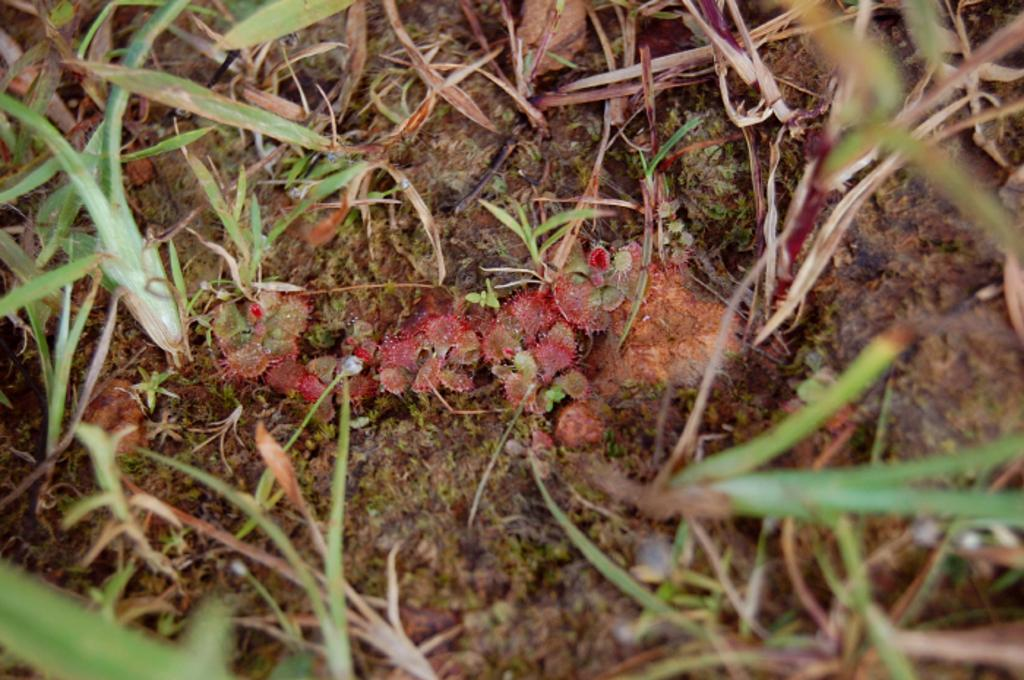What type of living organisms can be seen in the image? Plants can be seen in the image. How many girls are sleeping on the iron in the image? There are no girls or iron present in the image; it only features plants. 